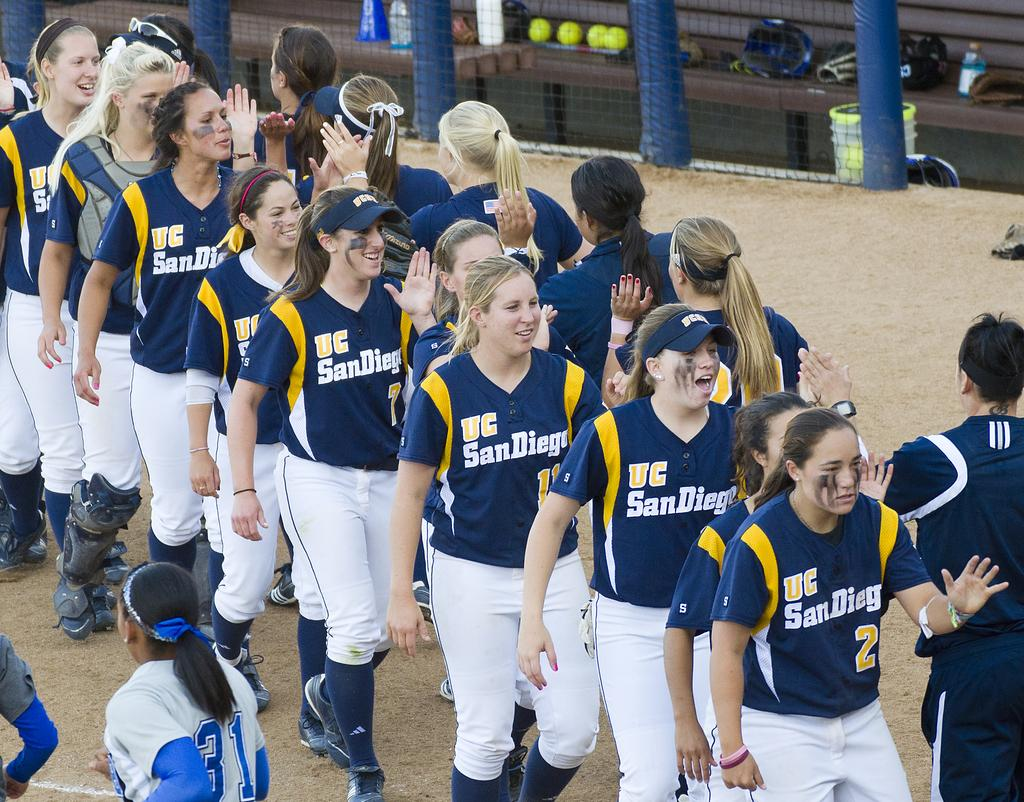Provide a one-sentence caption for the provided image. The team shown here is from the city of San Diego. 